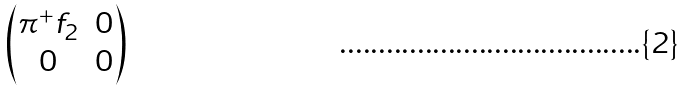<formula> <loc_0><loc_0><loc_500><loc_500>\begin{pmatrix} \pi ^ { + } f _ { 2 } & 0 \\ 0 & 0 \end{pmatrix}</formula> 